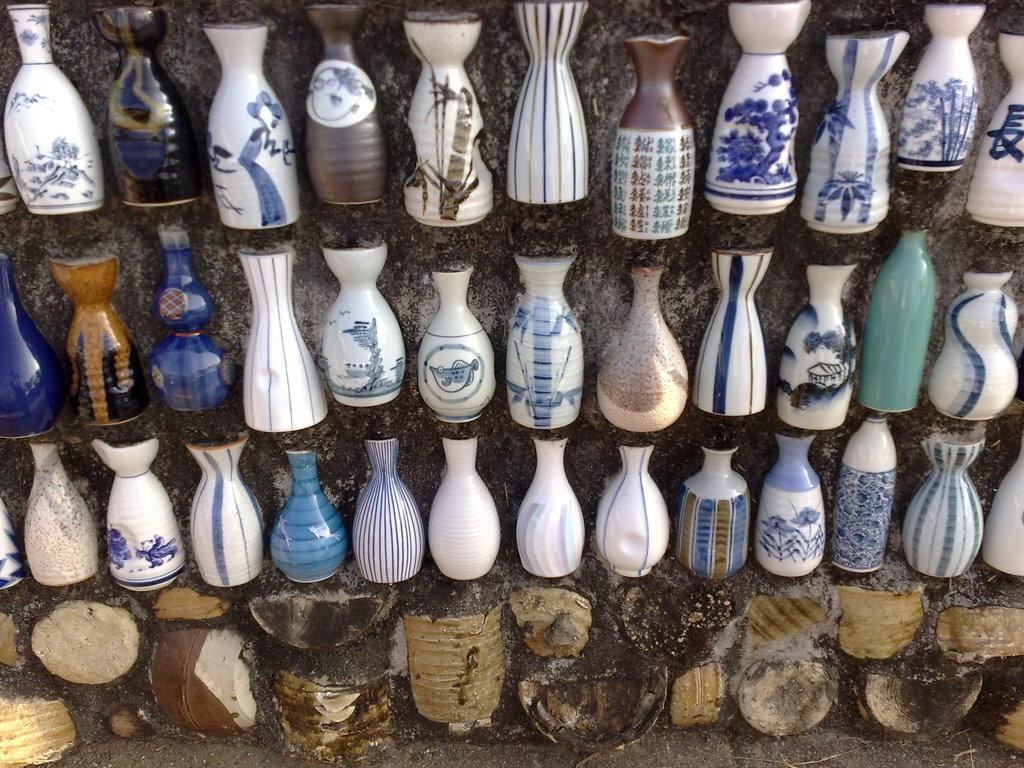What objects can be seen in the image? There are vases in the image. What is visible in the background of the image? There is a wall in the background of the image. What type of doll can be seen on the moon in the image? There is no doll or moon present in the image; it only features vases and a wall in the background. 